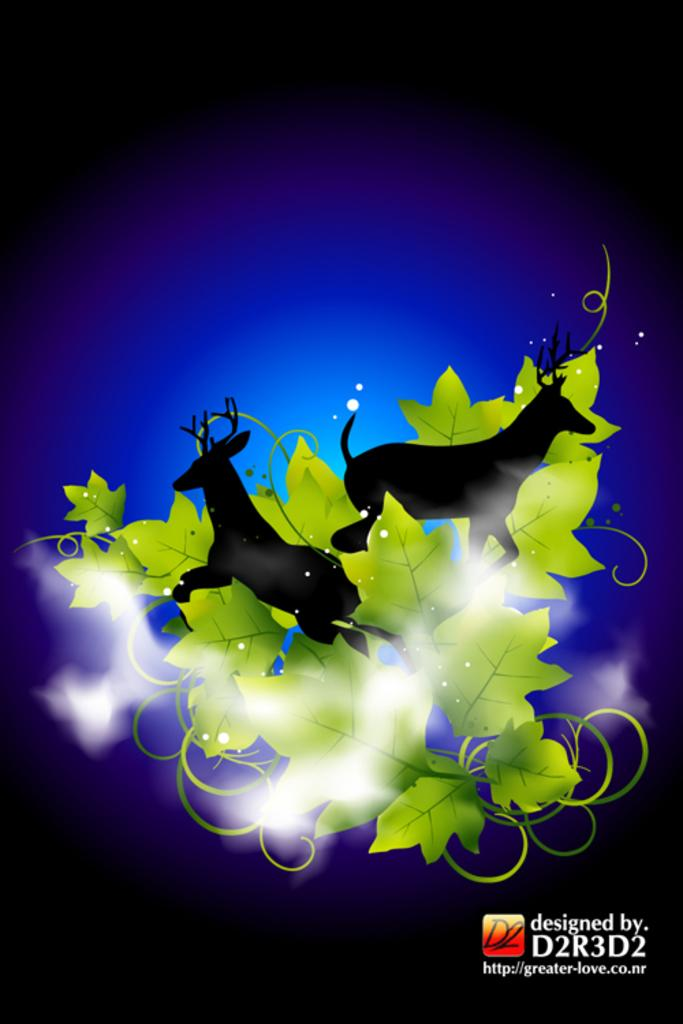What is the main subject of the poster in the image? The poster contains images of leaves and animals. What is the color of the background in the poster? The background of the poster is dark. Where is the text located in the image? The text is at the bottom of the image. What type of iron can be seen in the image? There is no iron present in the image. How many levels are visible in the image? The image does not depict any levels or structures with multiple floors. 